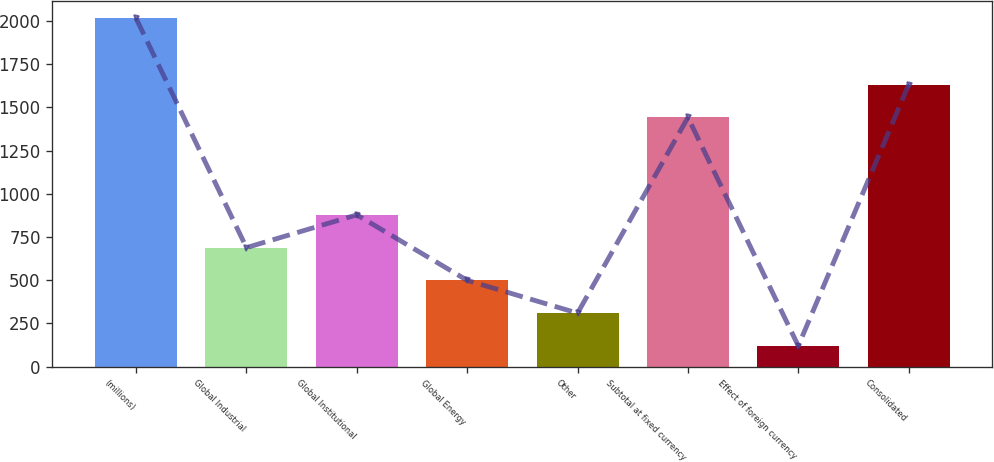Convert chart. <chart><loc_0><loc_0><loc_500><loc_500><bar_chart><fcel>(millions)<fcel>Global Industrial<fcel>Global Institutional<fcel>Global Energy<fcel>Other<fcel>Subtotal at fixed currency<fcel>Effect of foreign currency<fcel>Consolidated<nl><fcel>2015<fcel>688.36<fcel>877.88<fcel>498.84<fcel>309.32<fcel>1441.5<fcel>119.8<fcel>1631.02<nl></chart> 